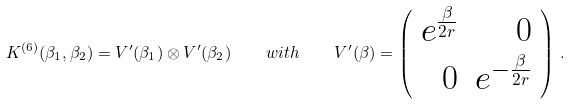<formula> <loc_0><loc_0><loc_500><loc_500>K ^ { ( 6 ) } ( \beta _ { 1 } , \beta _ { 2 } ) = V ^ { \prime } ( \beta _ { 1 } ) \otimes V ^ { \prime } ( \beta _ { 2 } ) \quad w i t h \quad V ^ { \prime } ( \beta ) = \left ( \begin{array} { r r } e ^ { \frac { \beta } { 2 r } } & 0 \\ 0 & e ^ { - \frac { \beta } { 2 r } } \\ \end{array} \right ) \, .</formula> 